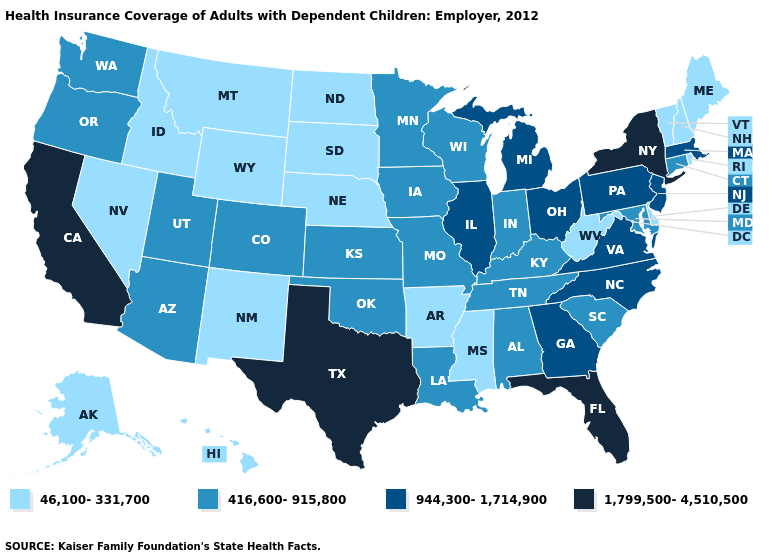Which states have the highest value in the USA?
Give a very brief answer. California, Florida, New York, Texas. Does Tennessee have a lower value than Texas?
Short answer required. Yes. Does Florida have the lowest value in the South?
Keep it brief. No. Among the states that border New Jersey , which have the highest value?
Keep it brief. New York. What is the lowest value in states that border Louisiana?
Give a very brief answer. 46,100-331,700. What is the value of Maine?
Be succinct. 46,100-331,700. What is the value of New Mexico?
Short answer required. 46,100-331,700. Name the states that have a value in the range 944,300-1,714,900?
Be succinct. Georgia, Illinois, Massachusetts, Michigan, New Jersey, North Carolina, Ohio, Pennsylvania, Virginia. What is the value of North Dakota?
Be succinct. 46,100-331,700. Does the first symbol in the legend represent the smallest category?
Be succinct. Yes. Does Colorado have a lower value than South Carolina?
Answer briefly. No. What is the value of West Virginia?
Be succinct. 46,100-331,700. Among the states that border Wyoming , does Colorado have the highest value?
Keep it brief. Yes. What is the value of Maryland?
Keep it brief. 416,600-915,800. Name the states that have a value in the range 416,600-915,800?
Quick response, please. Alabama, Arizona, Colorado, Connecticut, Indiana, Iowa, Kansas, Kentucky, Louisiana, Maryland, Minnesota, Missouri, Oklahoma, Oregon, South Carolina, Tennessee, Utah, Washington, Wisconsin. 